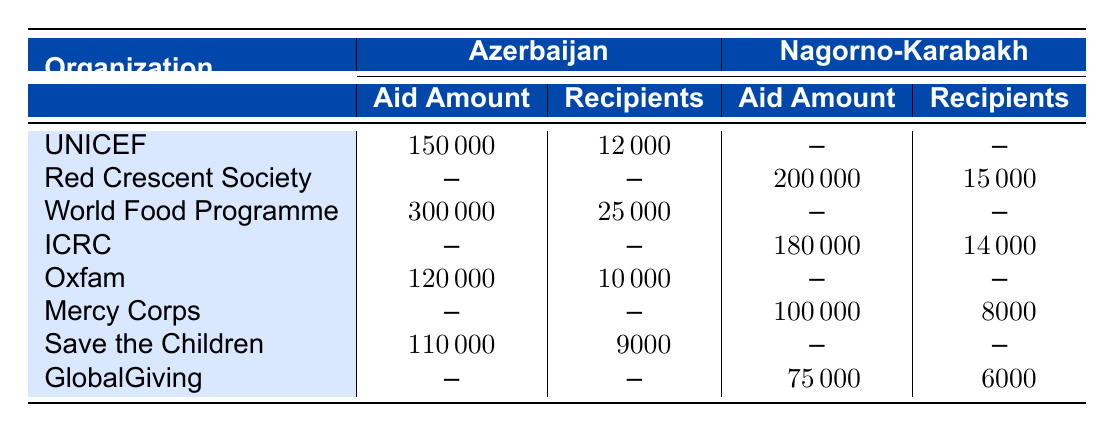What is the total aid amount distributed by UNICEF in Azerbaijan? The aid amount distributed by UNICEF in Azerbaijan is listed as 150000.
Answer: 150000 How many recipients did the World Food Programme serve in Azerbaijan? The number of recipients served by the World Food Programme in Azerbaijan is mentioned as 25000.
Answer: 25000 Which organization provided the highest aid amount in Nagorno-Karabakh? The organization providing the highest aid amount in Nagorno-Karabakh is the Red Crescent Society with an amount of 200000.
Answer: Red Crescent Society What is the total aid amount provided to Azerbaijan by all organizations combined? Adding the aid amounts from organizations in Azerbaijan: 150000 (UNICEF) + 300000 (World Food Programme) + 120000 (Oxfam) + 110000 (Save the Children) gives a total of 680000.
Answer: 680000 Did Mercy Corps distribute aid in Azerbaijan? Mercy Corps did not distribute aid in Azerbaijan according to the table; they only distributed aid in Nagorno-Karabakh.
Answer: No What is the average number of recipients across all organizations in Azerbaijan? The total number of recipients in Azerbaijan is 12000 (UNICEF) + 25000 (World Food Programme) + 10000 (Oxfam) + 9000 (Save the Children) = 56000. There are 4 organizations; hence the average is 56000 / 4 = 14000.
Answer: 14000 How much more aid did the World Food Programme distribute than Oxfam in Azerbaijan? The aid amount for the World Food Programme is 300000, and for Oxfam, it is 120000. The difference is 300000 - 120000 = 180000.
Answer: 180000 How many total recipients were assisted by organizations in Nagorno-Karabakh? The total recipients from organizations in Nagorno-Karabakh can be calculated as 15000 (Red Crescent Society) + 14000 (ICRC) + 8000 (Mercy Corps) + 6000 (GlobalGiving), which totals 43000.
Answer: 43000 Which organization had the least number of recipients in Nagorno-Karabakh? From the table, GlobalGiving had the least number of recipients in Nagorno-Karabakh, with a count of 6000.
Answer: GlobalGiving 